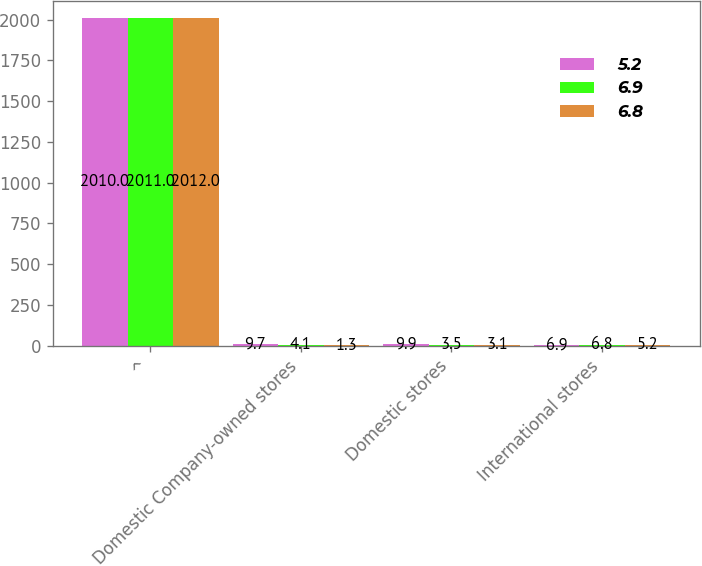Convert chart to OTSL. <chart><loc_0><loc_0><loc_500><loc_500><stacked_bar_chart><ecel><fcel>^<fcel>Domestic Company-owned stores<fcel>Domestic stores<fcel>International stores<nl><fcel>5.2<fcel>2010<fcel>9.7<fcel>9.9<fcel>6.9<nl><fcel>6.9<fcel>2011<fcel>4.1<fcel>3.5<fcel>6.8<nl><fcel>6.8<fcel>2012<fcel>1.3<fcel>3.1<fcel>5.2<nl></chart> 